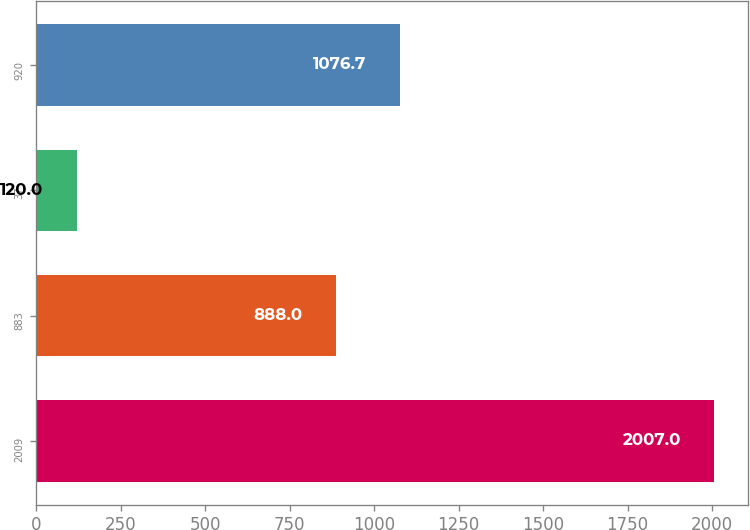Convert chart to OTSL. <chart><loc_0><loc_0><loc_500><loc_500><bar_chart><fcel>2009<fcel>883<fcel>37<fcel>920<nl><fcel>2007<fcel>888<fcel>120<fcel>1076.7<nl></chart> 